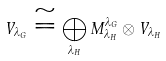<formula> <loc_0><loc_0><loc_500><loc_500>V _ { \lambda _ { G } } \cong \bigoplus _ { \lambda _ { H } } M ^ { \lambda _ { G } } _ { \lambda _ { H } } \otimes V _ { \lambda _ { H } }</formula> 